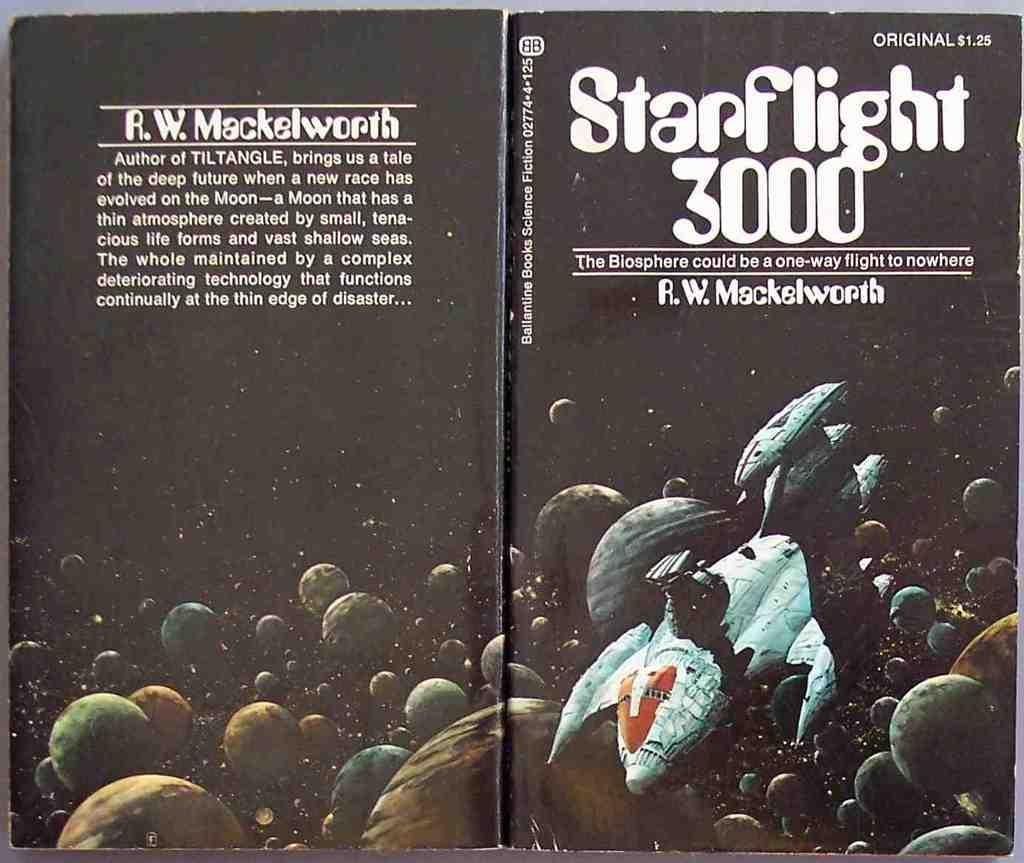<image>
Give a short and clear explanation of the subsequent image. An open book laying flat titled Starflight 3000 by R.W. Mackelworth.. 